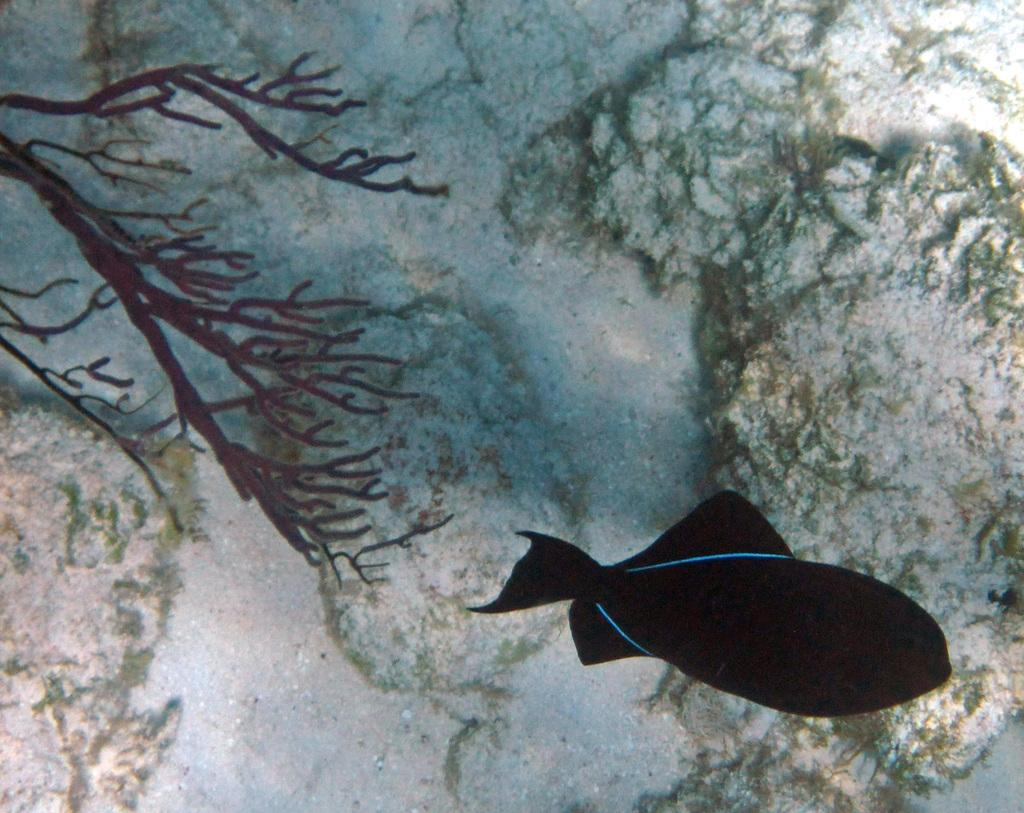What type of animal is in the image? There is a black fish in the image. What else can be seen in the image besides the fish? There are sea plants in the image. What type of underwear is the fish wearing in the image? Fish do not wear underwear, and there is no underwear present in the image. 